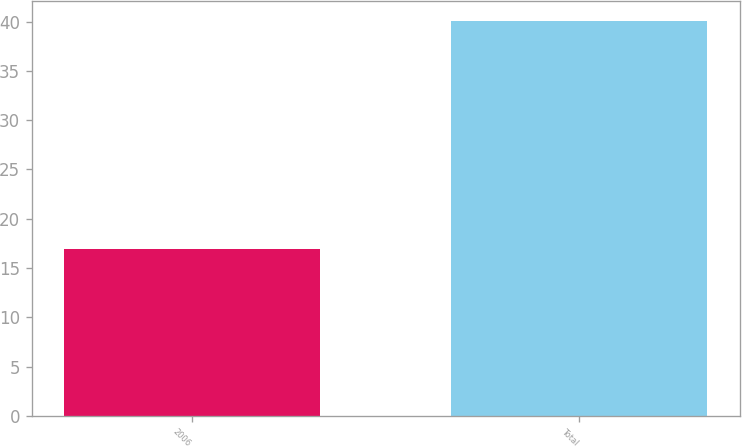<chart> <loc_0><loc_0><loc_500><loc_500><bar_chart><fcel>2006<fcel>Total<nl><fcel>16.9<fcel>40.1<nl></chart> 